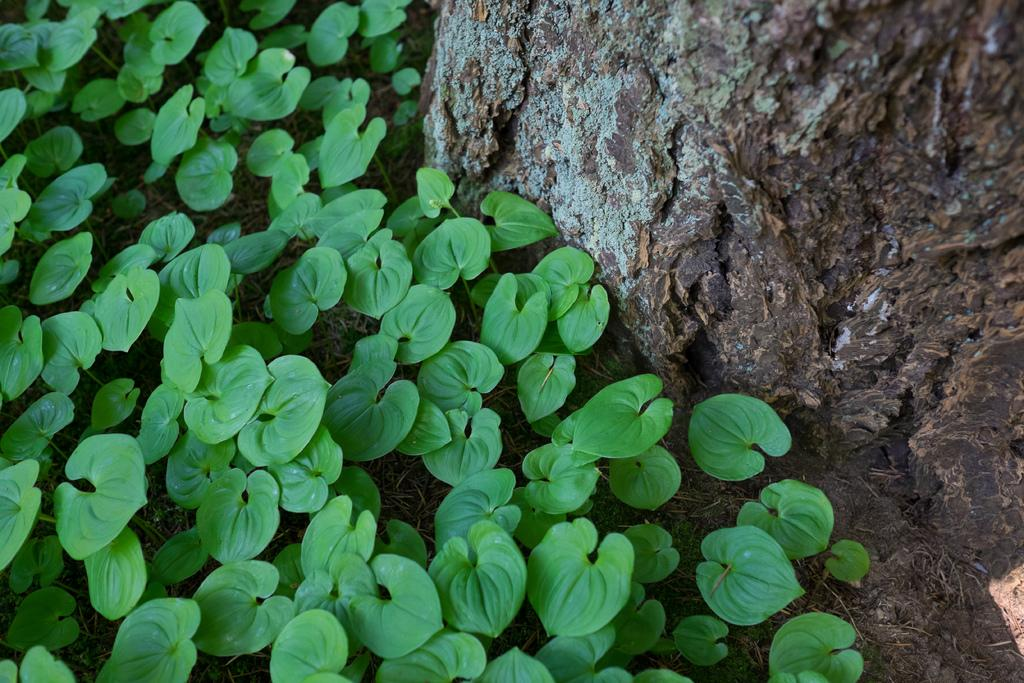What is the main object in the image? There is a tree branch in the image. What is present on the grass surface? There are leaves on the grass surface in the image. How much debt is the tree branch incurring in the image? There is no indication of debt in the image, as it features a tree branch and leaves on the grass surface. 